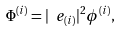<formula> <loc_0><loc_0><loc_500><loc_500>\Phi ^ { ( i ) } = | \ e _ { ( i ) } | ^ { 2 } \phi ^ { ( i ) } ,</formula> 